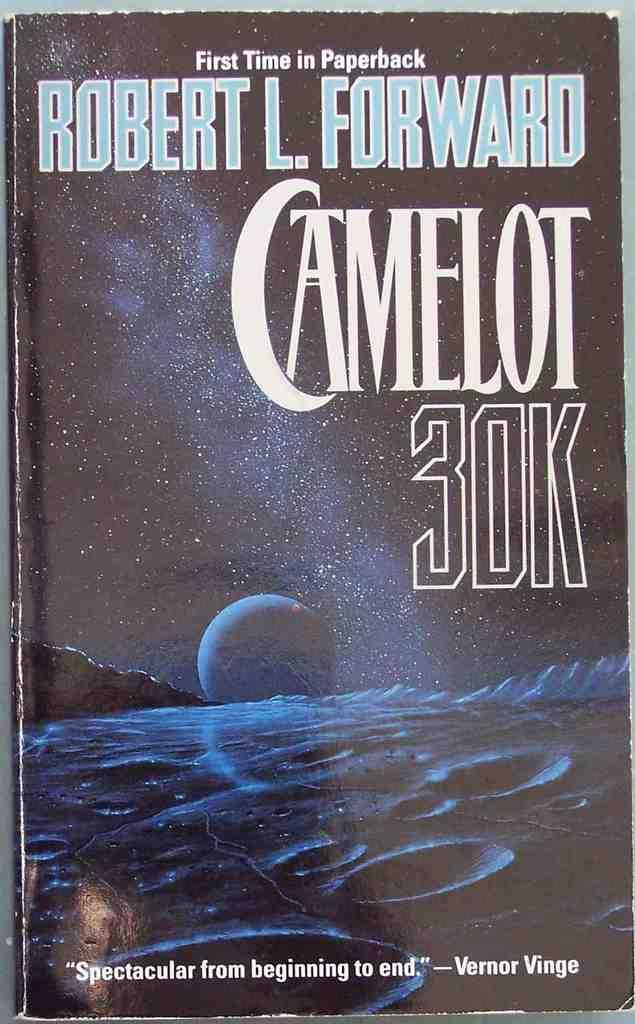Provide a one-sentence caption for the provided image. A book by Robert LForward, tittled Camelot 30k. 